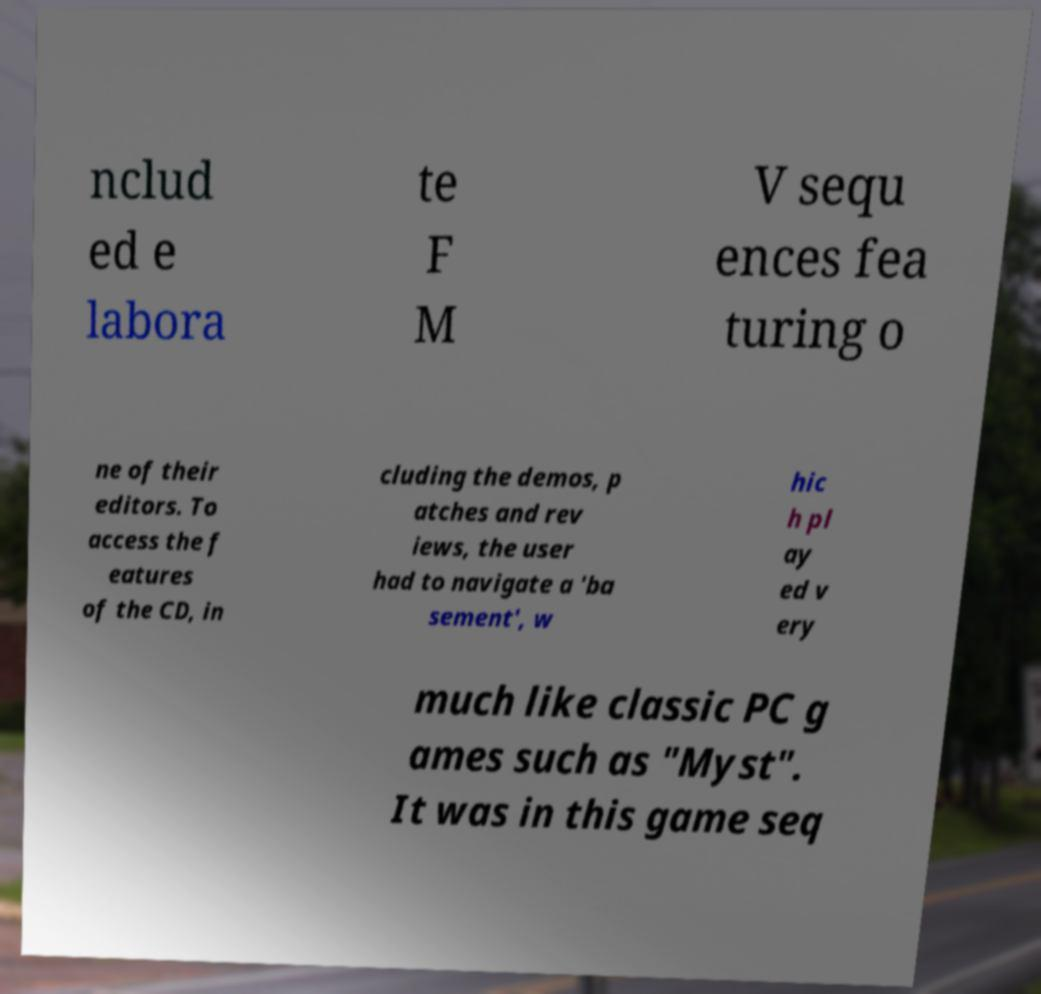Can you accurately transcribe the text from the provided image for me? nclud ed e labora te F M V sequ ences fea turing o ne of their editors. To access the f eatures of the CD, in cluding the demos, p atches and rev iews, the user had to navigate a 'ba sement', w hic h pl ay ed v ery much like classic PC g ames such as "Myst". It was in this game seq 